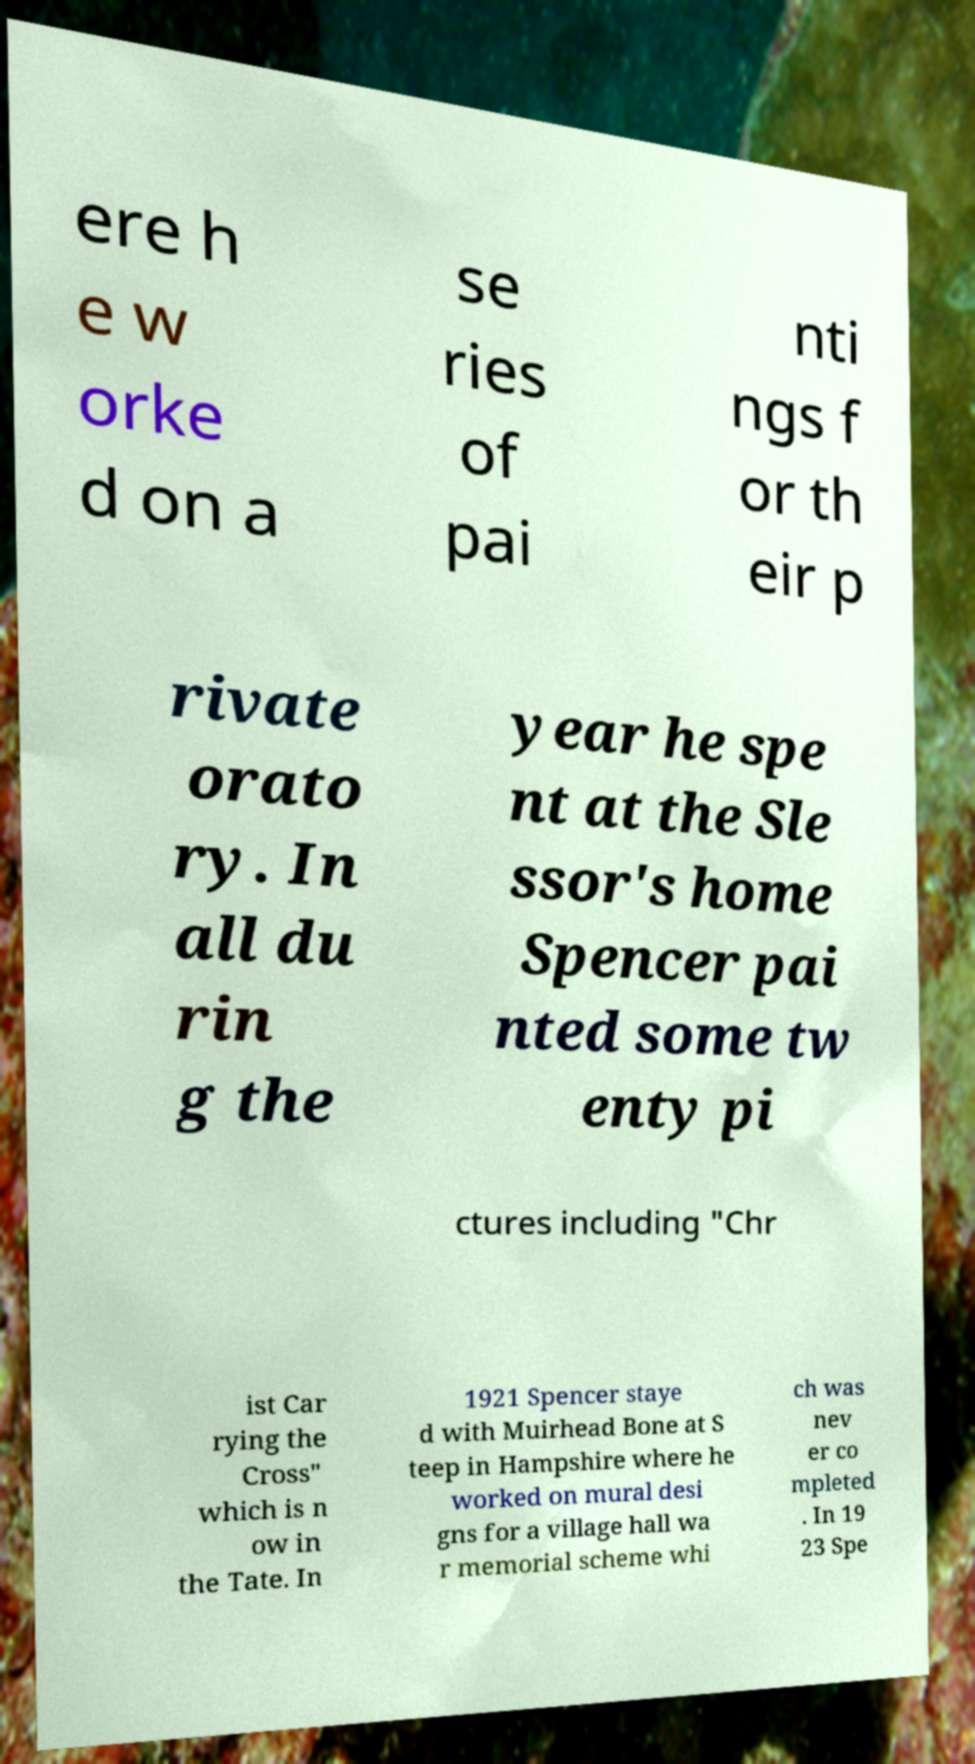For documentation purposes, I need the text within this image transcribed. Could you provide that? ere h e w orke d on a se ries of pai nti ngs f or th eir p rivate orato ry. In all du rin g the year he spe nt at the Sle ssor's home Spencer pai nted some tw enty pi ctures including "Chr ist Car rying the Cross" which is n ow in the Tate. In 1921 Spencer staye d with Muirhead Bone at S teep in Hampshire where he worked on mural desi gns for a village hall wa r memorial scheme whi ch was nev er co mpleted . In 19 23 Spe 